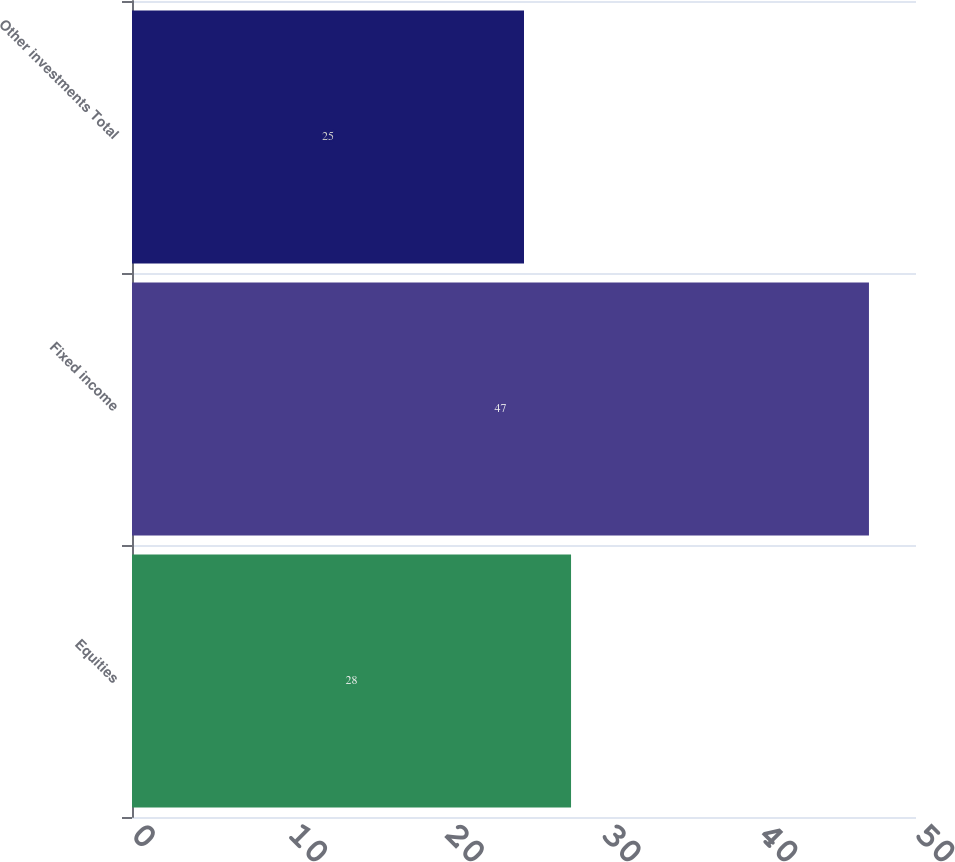<chart> <loc_0><loc_0><loc_500><loc_500><bar_chart><fcel>Equities<fcel>Fixed income<fcel>Other investments Total<nl><fcel>28<fcel>47<fcel>25<nl></chart> 